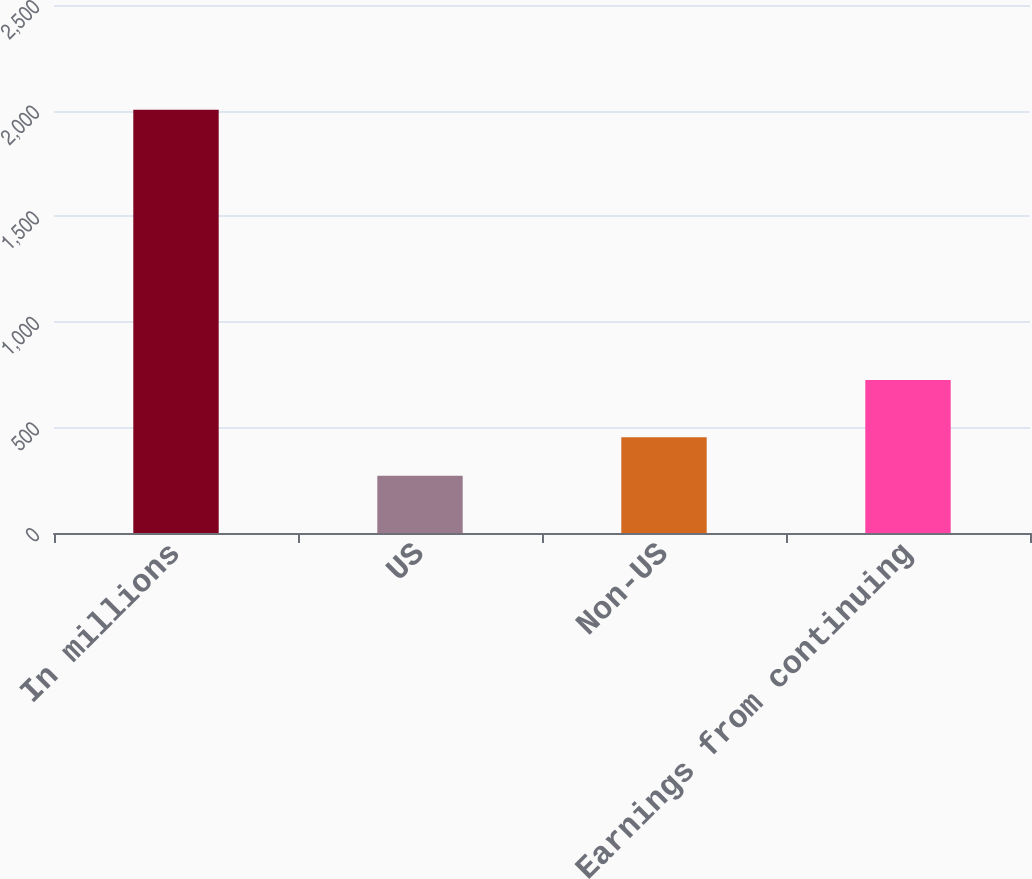Convert chart. <chart><loc_0><loc_0><loc_500><loc_500><bar_chart><fcel>In millions<fcel>US<fcel>Non-US<fcel>Earnings from continuing<nl><fcel>2004<fcel>271<fcel>453<fcel>724<nl></chart> 